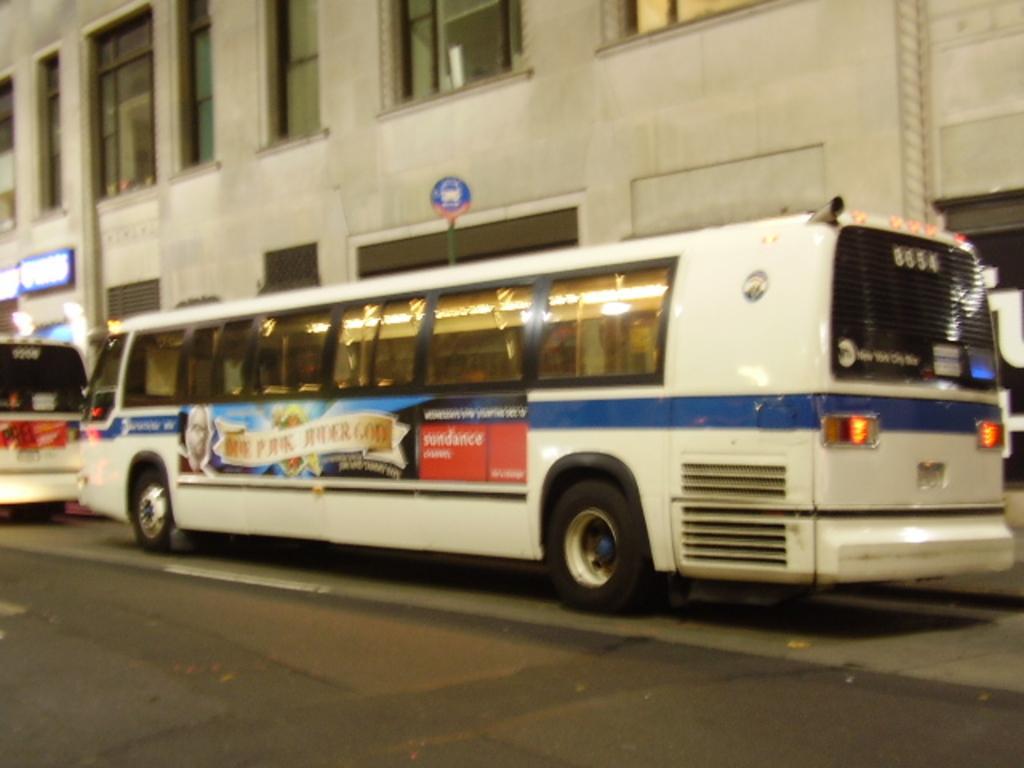Please provide a concise description of this image. In this image we can see vehicles on the road. In the background we can see a board on the pole, building, windows and hoardings on the wall. 